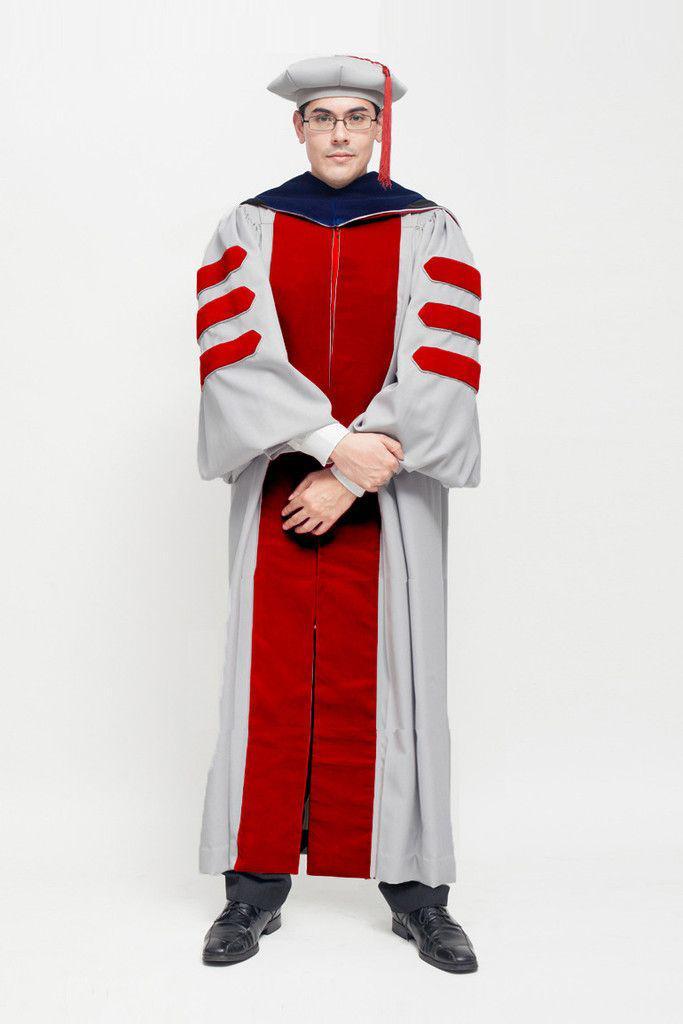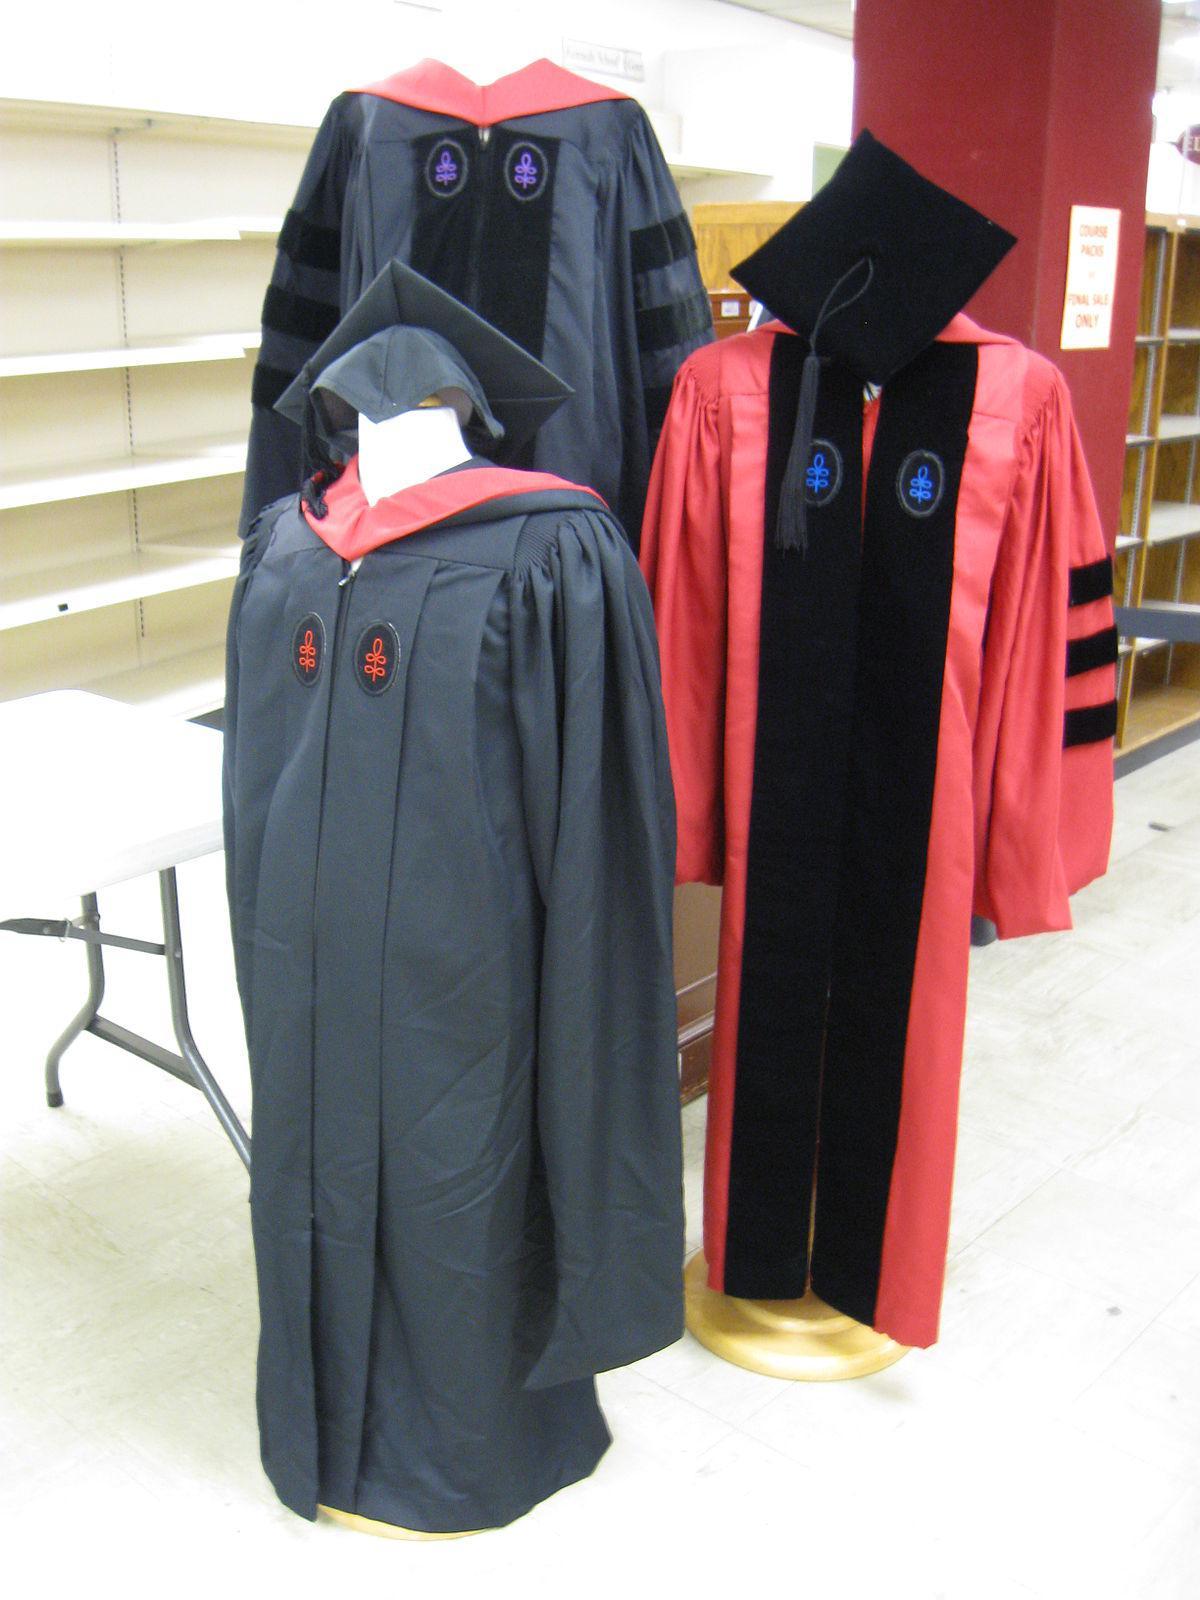The first image is the image on the left, the second image is the image on the right. Given the left and right images, does the statement "Each of the graduation gowns is being modeled by an actual person." hold true? Answer yes or no. No. The first image is the image on the left, the second image is the image on the right. Examine the images to the left and right. Is the description "One image shows a graduation outfit modeled by a real man, and the other image contains at least one graduation robe on a headless mannequin form." accurate? Answer yes or no. Yes. 